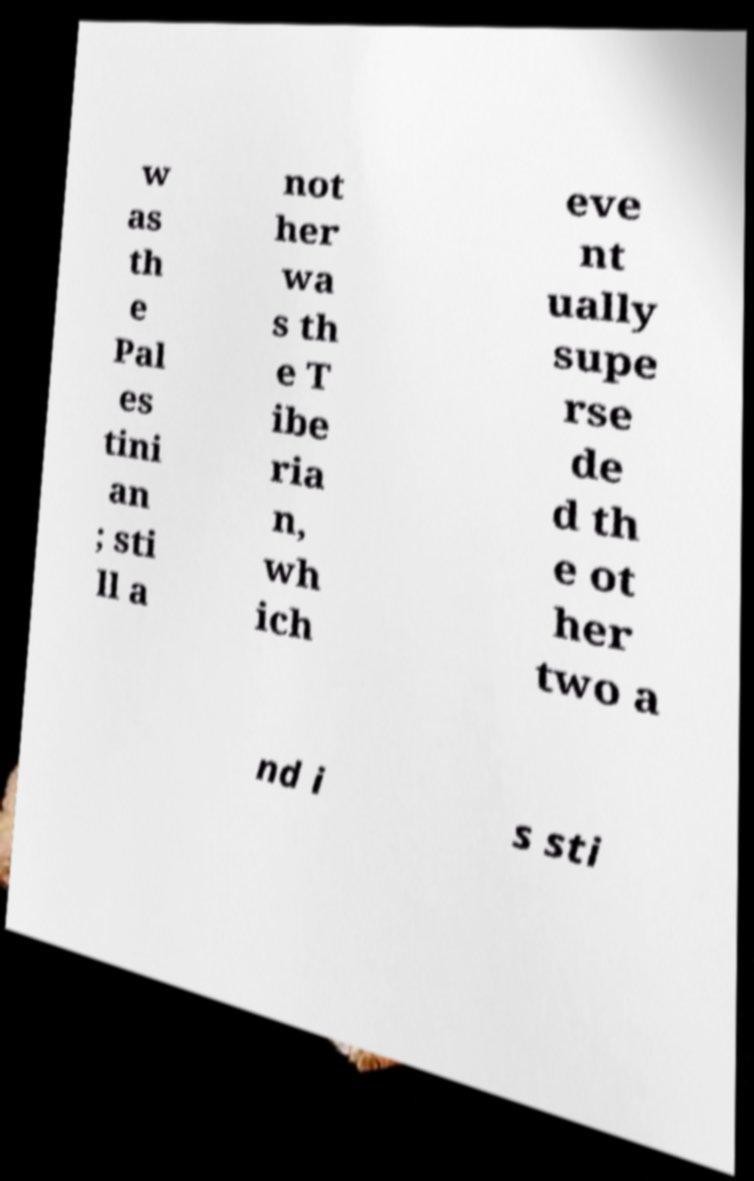Could you extract and type out the text from this image? w as th e Pal es tini an ; sti ll a not her wa s th e T ibe ria n, wh ich eve nt ually supe rse de d th e ot her two a nd i s sti 